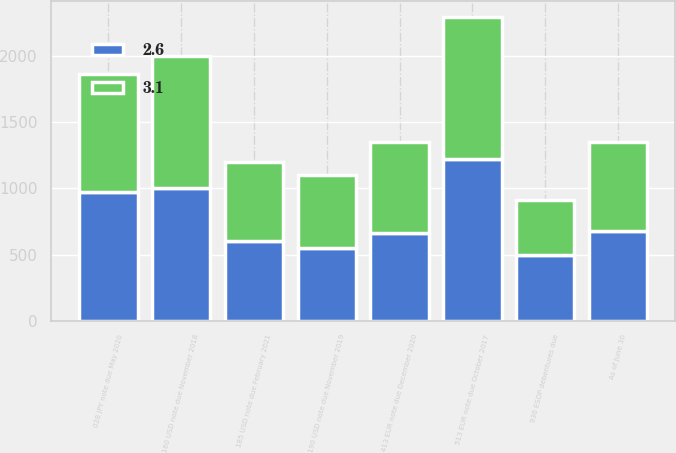Convert chart to OTSL. <chart><loc_0><loc_0><loc_500><loc_500><stacked_bar_chart><ecel><fcel>As of June 30<fcel>513 EUR note due October 2017<fcel>160 USD note due November 2018<fcel>190 USD note due November 2019<fcel>028 JPY note due May 2020<fcel>413 EUR note due December 2020<fcel>936 ESOP debentures due<fcel>185 USD note due February 2021<nl><fcel>3.1<fcel>676<fcel>1078<fcel>1000<fcel>550<fcel>894<fcel>686<fcel>417<fcel>600<nl><fcel>2.6<fcel>676<fcel>1221<fcel>1000<fcel>550<fcel>973<fcel>666<fcel>498<fcel>600<nl></chart> 